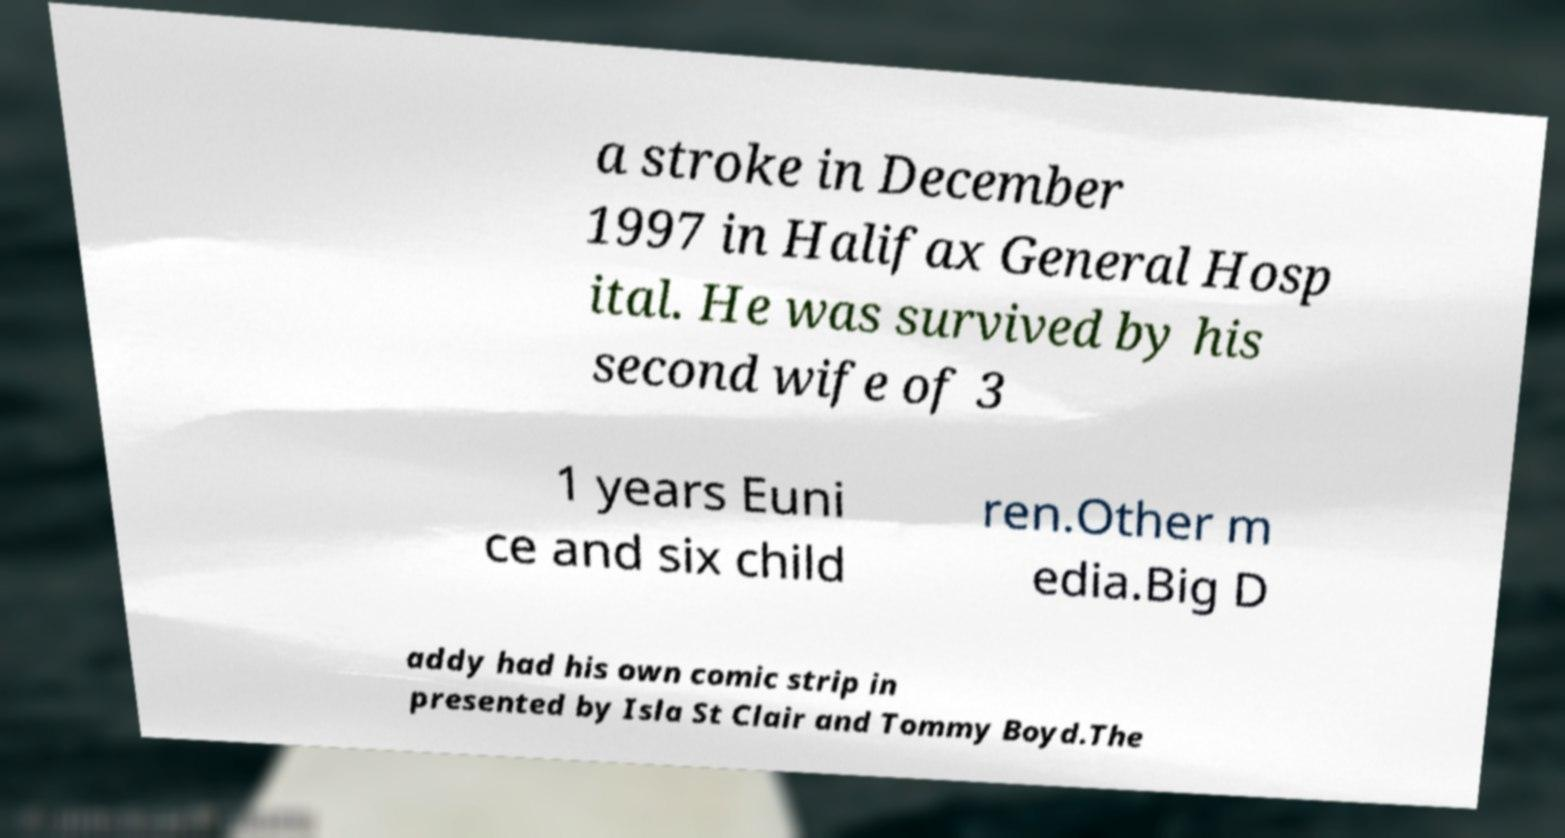There's text embedded in this image that I need extracted. Can you transcribe it verbatim? a stroke in December 1997 in Halifax General Hosp ital. He was survived by his second wife of 3 1 years Euni ce and six child ren.Other m edia.Big D addy had his own comic strip in presented by Isla St Clair and Tommy Boyd.The 